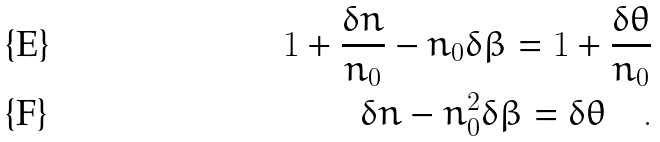Convert formula to latex. <formula><loc_0><loc_0><loc_500><loc_500>1 + \frac { \delta n } { n _ { 0 } } - n _ { 0 } \delta \beta = 1 + \frac { \delta \theta } { n _ { 0 } } \\ \delta n - n _ { 0 } ^ { 2 } \delta \beta = \delta \theta \quad .</formula> 